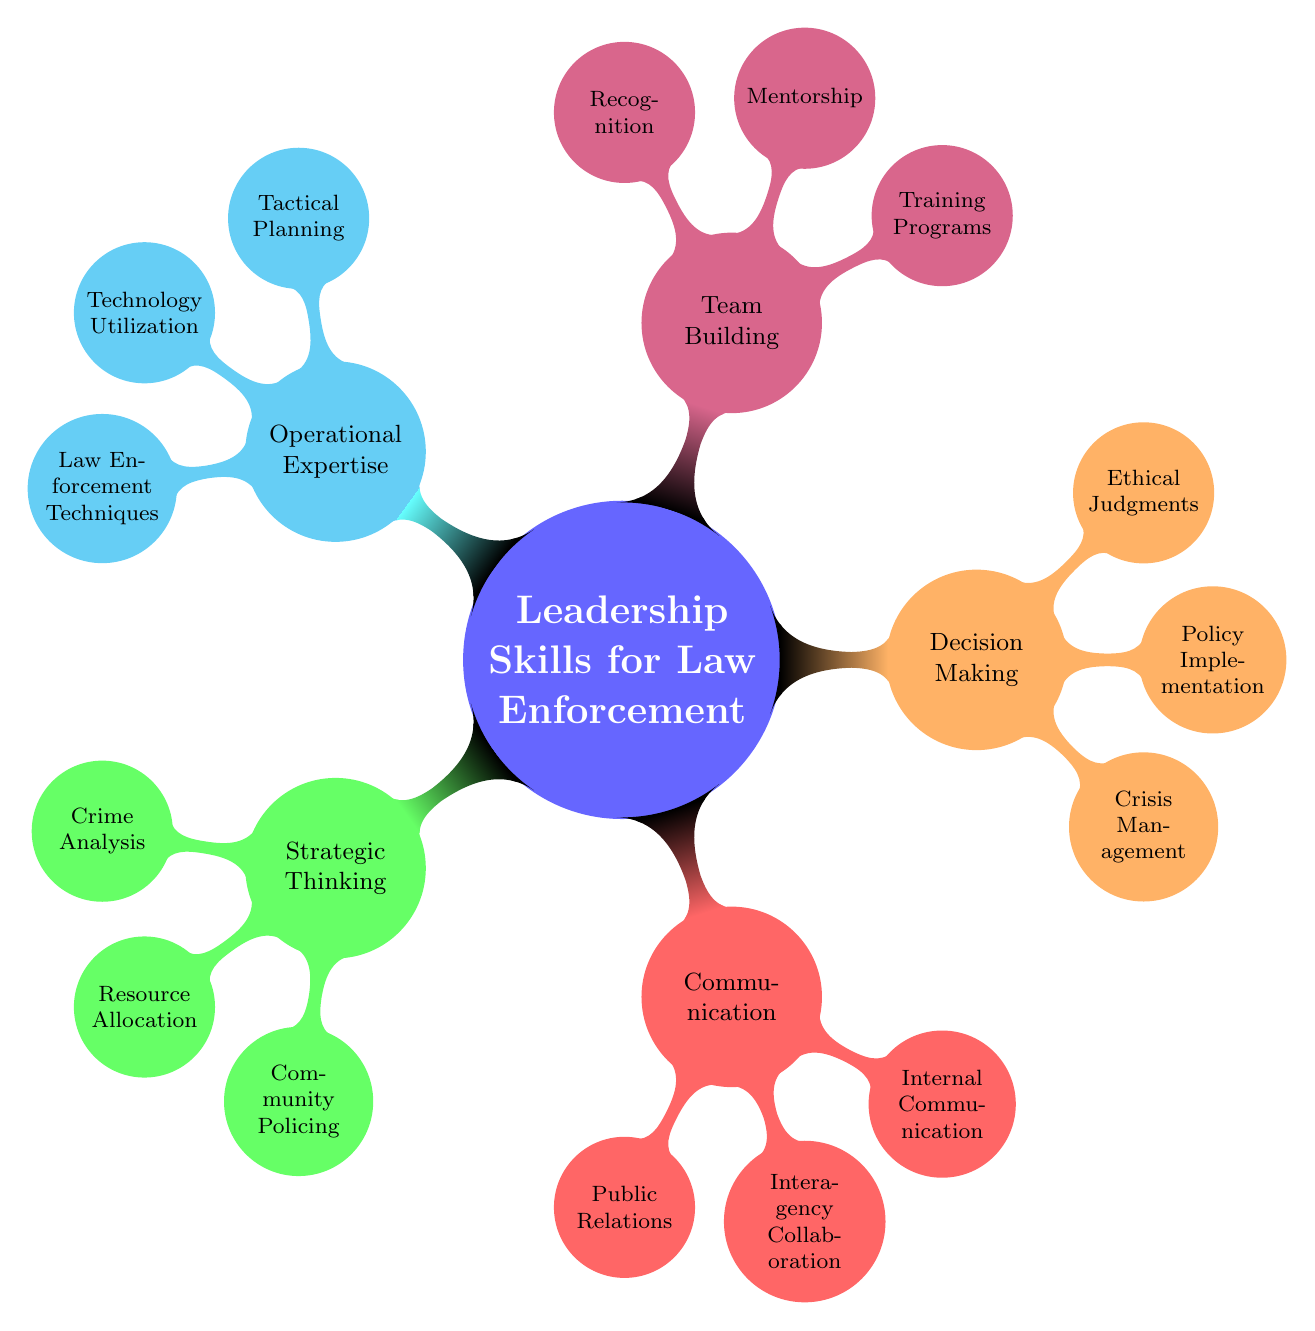What is the main topic of the diagram? The central node of the mind map is labeled “Leadership Skills for Law Enforcement,” which defines the main topic depicted in the diagram.
Answer: Leadership Skills for Law Enforcement How many main categories are in the diagram? The diagram contains five main categories branching out from the central node: Strategic Thinking, Communication, Decision Making, Team Building, and Operational Expertise. Counting these, we find there are five primary branches.
Answer: 5 What is one subcategory under Communication? Under the Communication category, one of the subcategories is Public Relations. This can be directly identified by looking at the second level of the branch coming from the Communication node.
Answer: Public Relations Which category includes Crisis Management? Crisis Management is located under the Decision Making category, which is a top-level node. It can be identified by following the branch labeled Decision Making to its subcategory Crisis Management.
Answer: Decision Making What are the three subcategories under Team Building? The subcategories under Team Building are Training Programs, Mentorship, and Recognition. These can be found by examining the nodes connected to the Team Building branch.
Answer: Training Programs, Mentorship, Recognition What skill is associated with leveraging new technologies? The skill associated with leveraging new technologies is Technology Utilization, which is a subcategory found under Operational Expertise. This is determined by tracing the Operational Expertise node down to its subcategory.
Answer: Technology Utilization Which two categories have more than two subcategories? The categories with more than two subcategories are Communication (which has three: Public Relations, Interagency Collaboration, and Internal Communication) and Decision Making (which has three: Crisis Management, Policy Implementation, and Ethical Judgments). This is concluded by counting the nodes under each of these categories.
Answer: Communication, Decision Making What does the subcategory Community Policing focus on? The subcategory Community Policing focuses on building partnerships with community members. This information can be found directly as a descriptor under the Community Policing node.
Answer: Building partnerships with community members List the three subcategories under Operational Expertise. The subcategories under Operational Expertise are Tactical Planning, Technology Utilization, and Law Enforcement Techniques. This can be confirmed by examining the direct connections stemming from the Operational Expertise branch.
Answer: Tactical Planning, Technology Utilization, Law Enforcement Techniques 